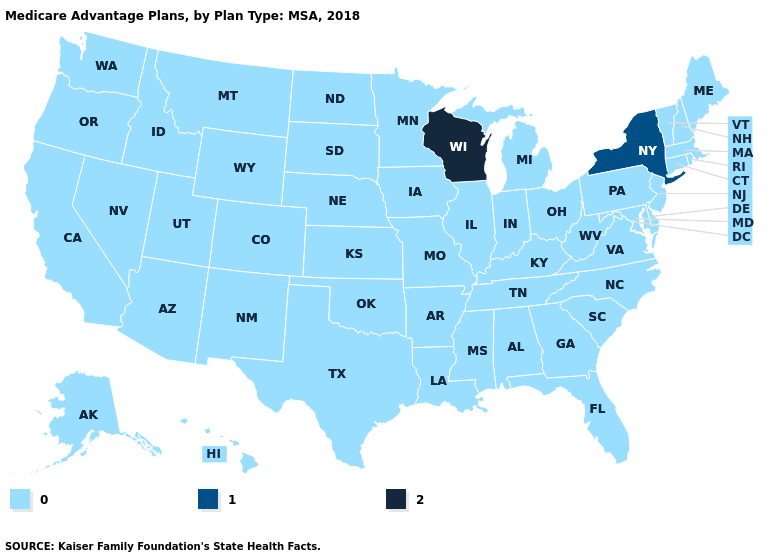What is the highest value in the South ?
Answer briefly. 0. How many symbols are there in the legend?
Be succinct. 3. What is the value of Minnesota?
Answer briefly. 0. What is the lowest value in the USA?
Write a very short answer. 0. What is the value of New Hampshire?
Be succinct. 0. Name the states that have a value in the range 2?
Be succinct. Wisconsin. Does Minnesota have the highest value in the MidWest?
Quick response, please. No. What is the lowest value in the South?
Keep it brief. 0. Does the map have missing data?
Write a very short answer. No. What is the value of South Carolina?
Answer briefly. 0. Name the states that have a value in the range 2?
Keep it brief. Wisconsin. Which states have the lowest value in the USA?
Give a very brief answer. Alaska, Alabama, Arkansas, Arizona, California, Colorado, Connecticut, Delaware, Florida, Georgia, Hawaii, Iowa, Idaho, Illinois, Indiana, Kansas, Kentucky, Louisiana, Massachusetts, Maryland, Maine, Michigan, Minnesota, Missouri, Mississippi, Montana, North Carolina, North Dakota, Nebraska, New Hampshire, New Jersey, New Mexico, Nevada, Ohio, Oklahoma, Oregon, Pennsylvania, Rhode Island, South Carolina, South Dakota, Tennessee, Texas, Utah, Virginia, Vermont, Washington, West Virginia, Wyoming. What is the value of Missouri?
Give a very brief answer. 0. 